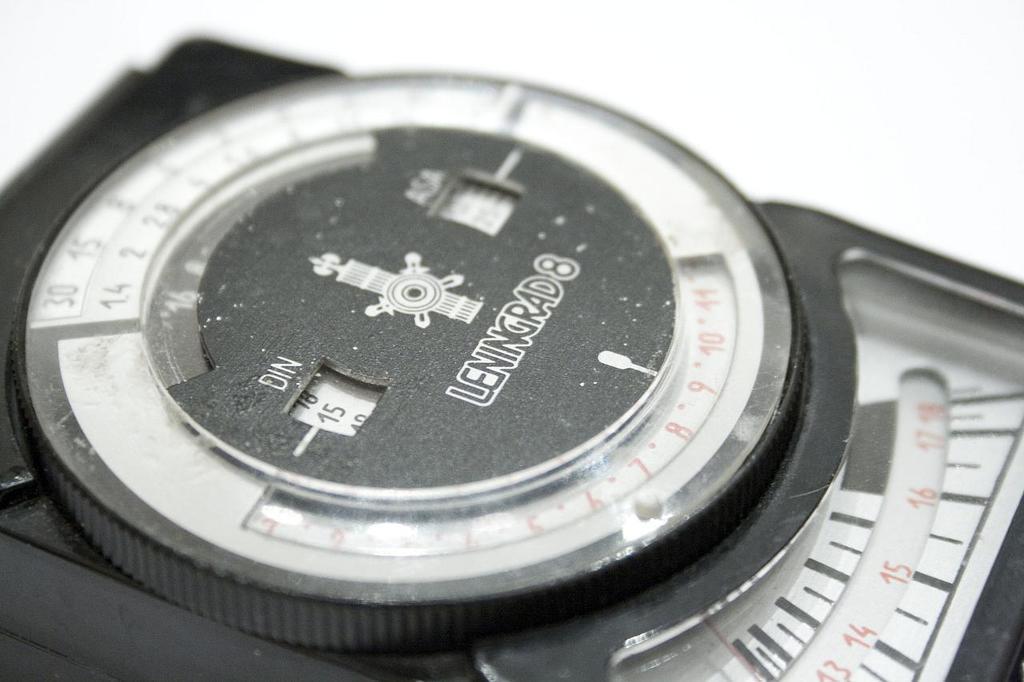What number comes after the brand name?
Make the answer very short. 8. What is the brand of the watch?
Your response must be concise. Leningrad8. 